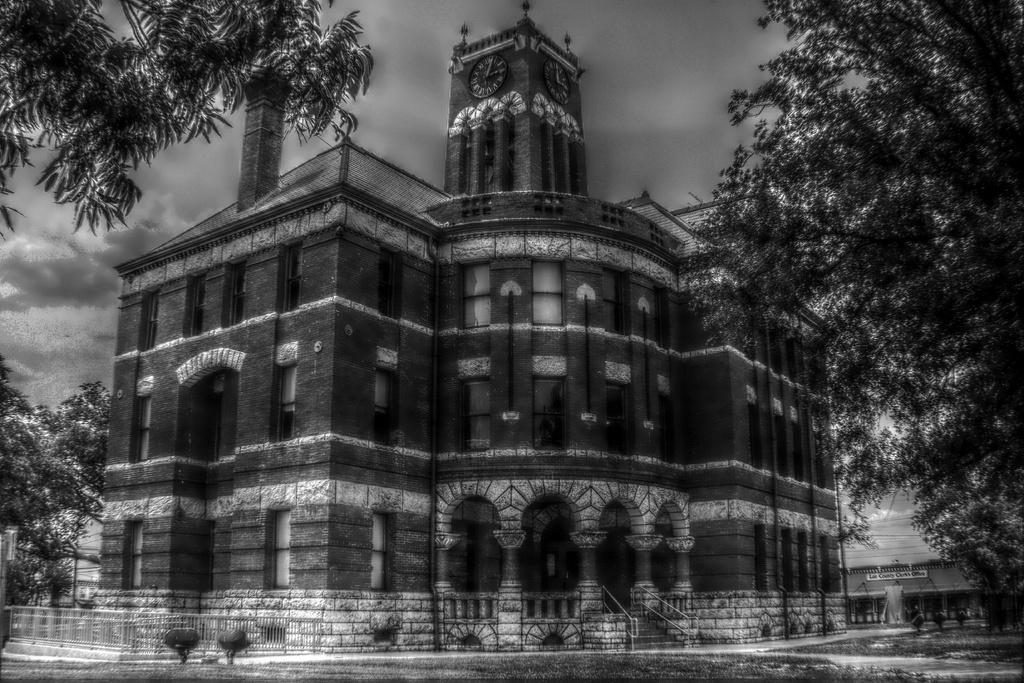In one or two sentences, can you explain what this image depicts? This is a black and white image. In the middle of this image there is a building. At the bottom, I can see the road. On the right and left side of the image there are trees. At the top of the image I can see the sky and it is cloudy. At the top of the building there is a clock tower. 